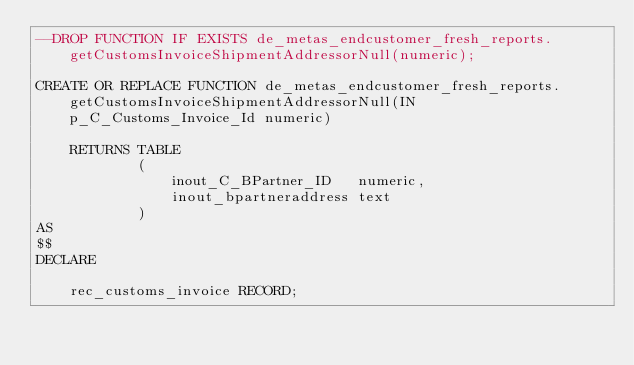<code> <loc_0><loc_0><loc_500><loc_500><_SQL_>--DROP FUNCTION IF EXISTS de_metas_endcustomer_fresh_reports.getCustomsInvoiceShipmentAddressorNull(numeric);

CREATE OR REPLACE FUNCTION de_metas_endcustomer_fresh_reports.getCustomsInvoiceShipmentAddressorNull(IN p_C_Customs_Invoice_Id numeric)

    RETURNS TABLE
            (
                inout_C_BPartner_ID   numeric,
                inout_bpartneraddress text
            )
AS
$$
DECLARE

    rec_customs_invoice RECORD;</code> 